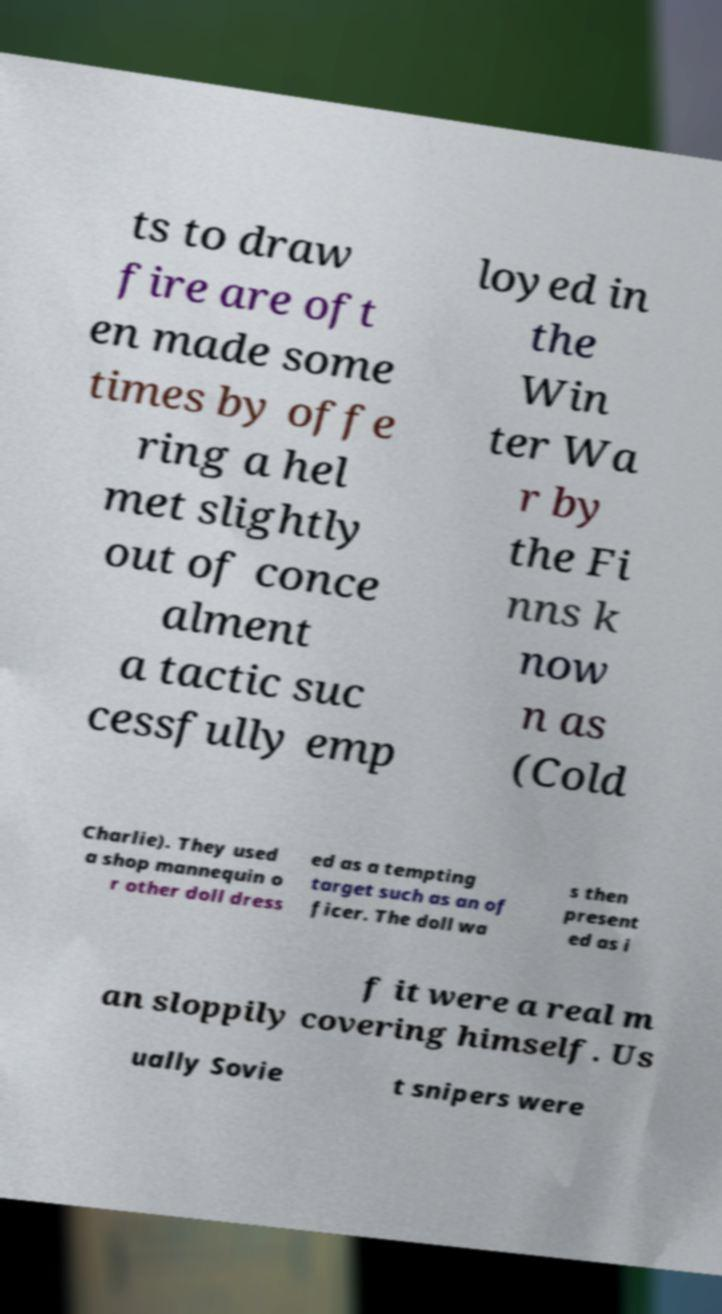What messages or text are displayed in this image? I need them in a readable, typed format. ts to draw fire are oft en made some times by offe ring a hel met slightly out of conce alment a tactic suc cessfully emp loyed in the Win ter Wa r by the Fi nns k now n as (Cold Charlie). They used a shop mannequin o r other doll dress ed as a tempting target such as an of ficer. The doll wa s then present ed as i f it were a real m an sloppily covering himself. Us ually Sovie t snipers were 